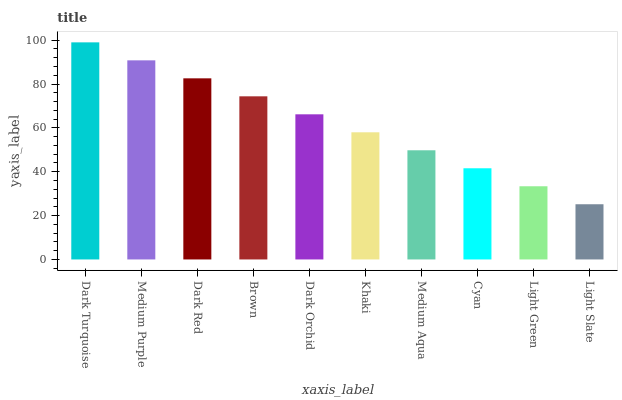Is Light Slate the minimum?
Answer yes or no. Yes. Is Dark Turquoise the maximum?
Answer yes or no. Yes. Is Medium Purple the minimum?
Answer yes or no. No. Is Medium Purple the maximum?
Answer yes or no. No. Is Dark Turquoise greater than Medium Purple?
Answer yes or no. Yes. Is Medium Purple less than Dark Turquoise?
Answer yes or no. Yes. Is Medium Purple greater than Dark Turquoise?
Answer yes or no. No. Is Dark Turquoise less than Medium Purple?
Answer yes or no. No. Is Dark Orchid the high median?
Answer yes or no. Yes. Is Khaki the low median?
Answer yes or no. Yes. Is Dark Turquoise the high median?
Answer yes or no. No. Is Medium Purple the low median?
Answer yes or no. No. 